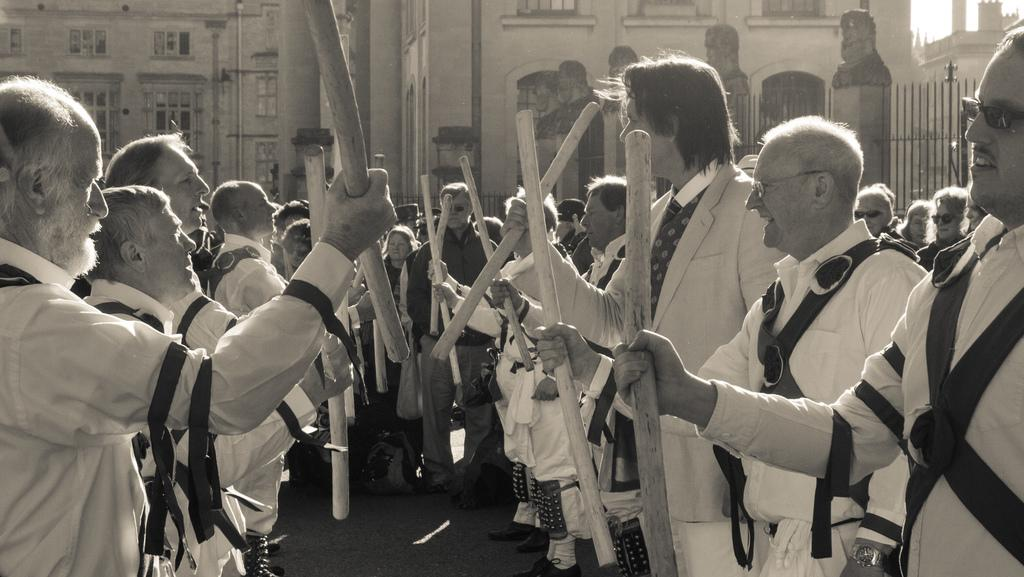What is the color scheme of the image? The image is black and white. What are the people in the image doing? The people are standing in the image and holding sticks. What can be seen in the background of the image? There are buildings, fencing, and statues in the background. Can you tell me how many rabbits are hopping around in the image? There are no rabbits present in the image. What type of pipe is being used by the people in the image? There are no pipes visible in the image; the people are holding sticks. 